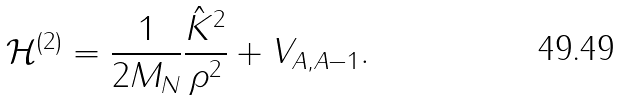<formula> <loc_0><loc_0><loc_500><loc_500>\mathcal { H } ^ { ( 2 ) } = \frac { 1 } { 2 M _ { N } } \frac { \hat { K } ^ { 2 } } { \rho ^ { 2 } } + V _ { A , A - 1 } .</formula> 